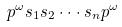Convert formula to latex. <formula><loc_0><loc_0><loc_500><loc_500>p ^ { \omega } s _ { 1 } s _ { 2 } \cdot \cdot \cdot s _ { n } p ^ { \omega }</formula> 